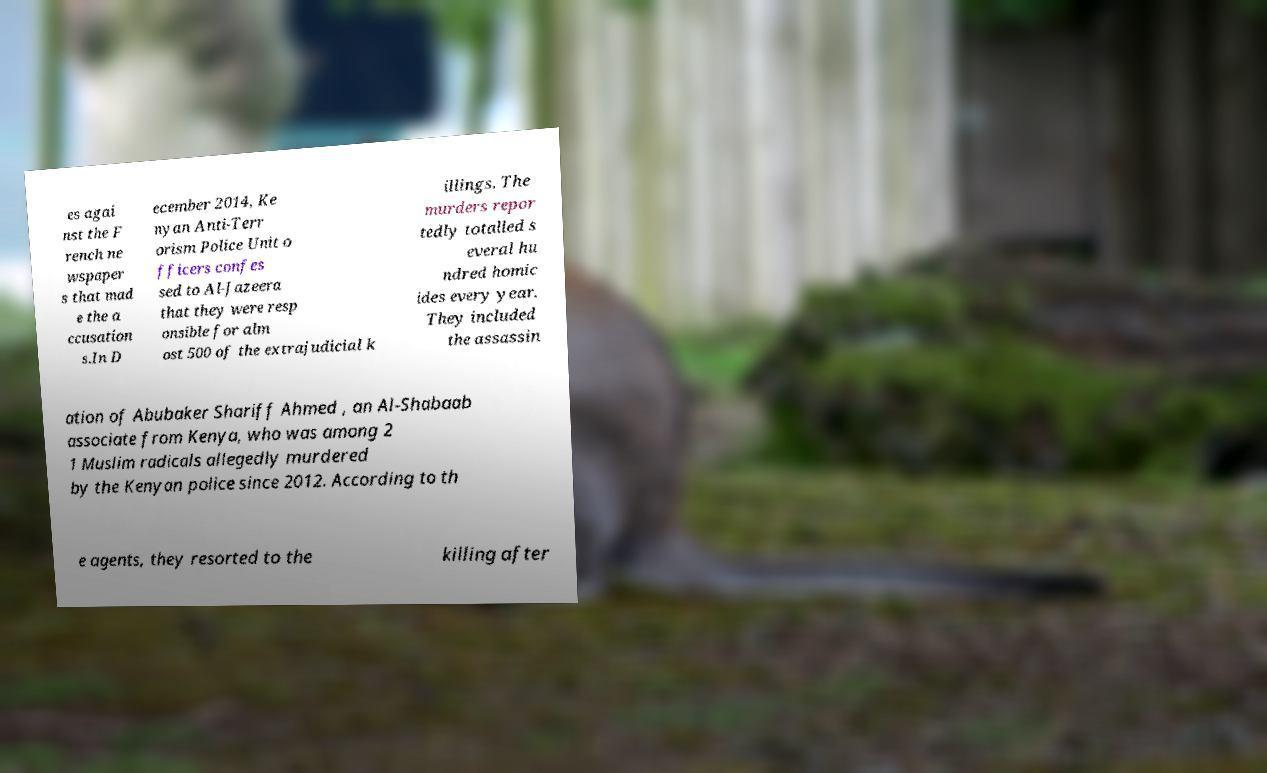Can you accurately transcribe the text from the provided image for me? es agai nst the F rench ne wspaper s that mad e the a ccusation s.In D ecember 2014, Ke nyan Anti-Terr orism Police Unit o fficers confes sed to Al-Jazeera that they were resp onsible for alm ost 500 of the extrajudicial k illings. The murders repor tedly totalled s everal hu ndred homic ides every year. They included the assassin ation of Abubaker Shariff Ahmed , an Al-Shabaab associate from Kenya, who was among 2 1 Muslim radicals allegedly murdered by the Kenyan police since 2012. According to th e agents, they resorted to the killing after 